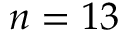<formula> <loc_0><loc_0><loc_500><loc_500>n = 1 3</formula> 